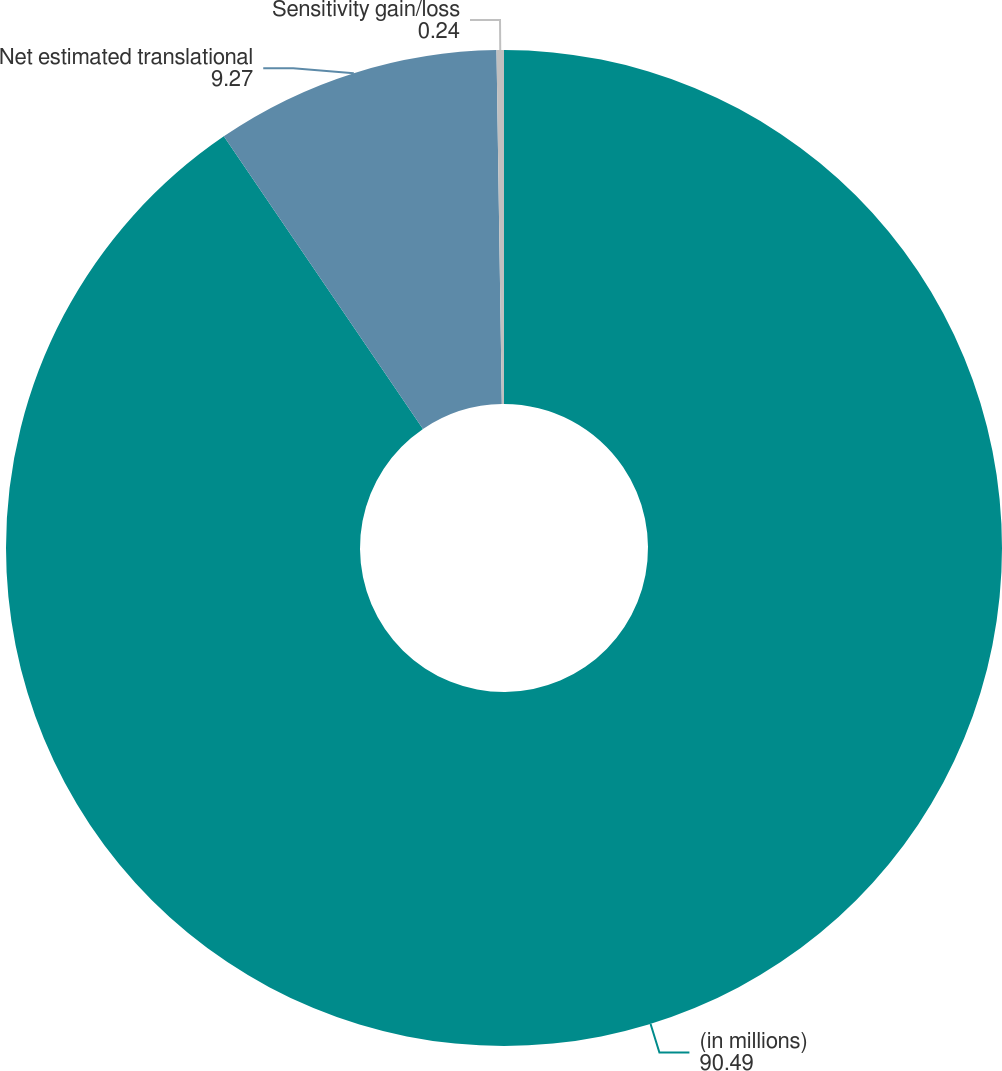Convert chart. <chart><loc_0><loc_0><loc_500><loc_500><pie_chart><fcel>(in millions)<fcel>Net estimated translational<fcel>Sensitivity gain/loss<nl><fcel>90.49%<fcel>9.27%<fcel>0.24%<nl></chart> 